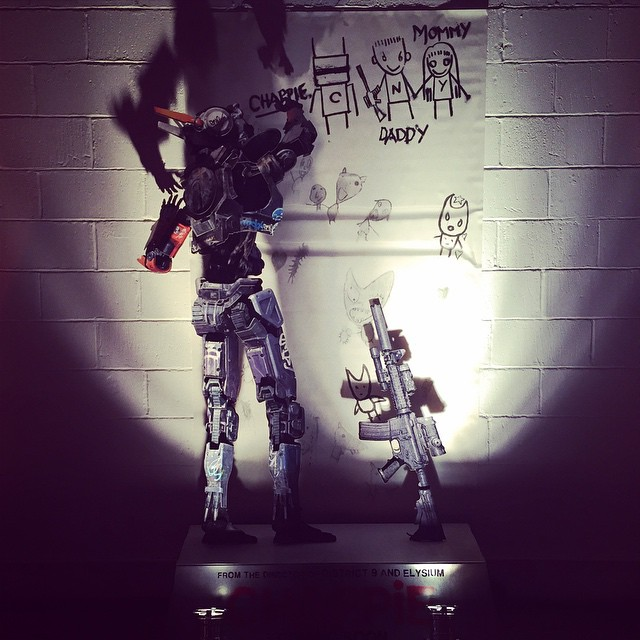What role could this robot play in a realistic day-to-day family scenario? In a realistic day-to-day family scenario, this robot could act as a guardian and caretaker. It might help with household chores, provide security, assist children with their homework, and even engage them in creative activities like drawing or storytelling. The robot’s presence would offer parents peace of mind, knowing there’s an additional layer of safety and support for their children, fostering a harmonious and efficient home environment. 